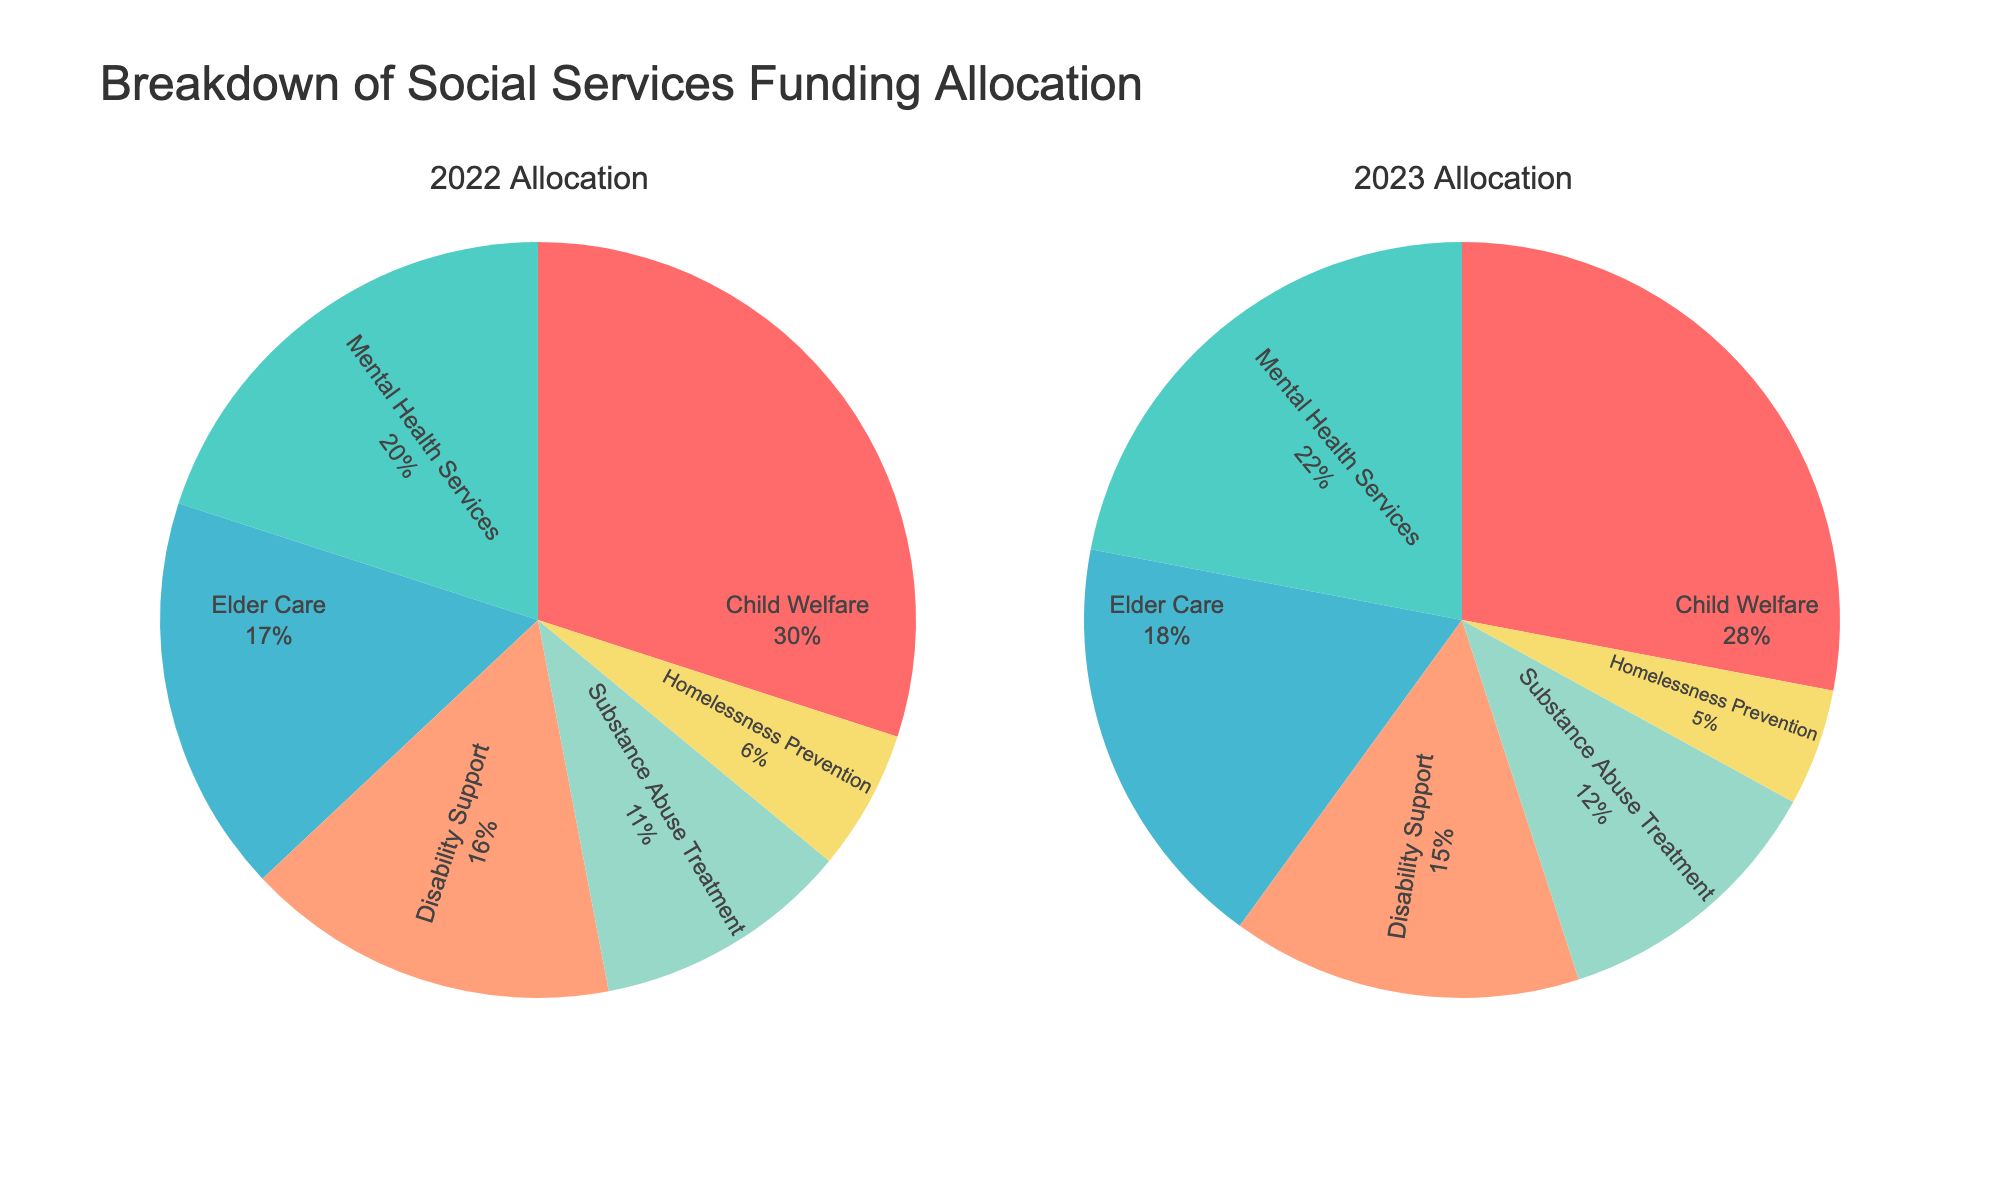Which category received the largest allocation in 2023? By looking at the biggest segment in the 2023 pie chart, we see that Child Welfare has the largest allocation.
Answer: Child Welfare Which category had the smallest percentage allocation in 2022? Looking at the smallest segment in the 2022 pie chart, we see that Homelessness Prevention has the smallest percentage allocation.
Answer: Homelessness Prevention What is the total percentage of allocations for Child Welfare and Mental Health Services in 2023? In the 2023 pie chart, Child Welfare is 28% and Mental Health Services is 22%. Adding these percentages together: 28% + 22% = 50%.
Answer: 50% Which category had an increased percentage of allocation from 2022 to 2023? By comparing the pie charts for both years, we see that the percentages for Mental Health Services and Substance Abuse Treatment increased from 2022 to 2023 (20% to 22% and 11% to 12%, respectively).
Answer: Mental Health Services, Substance Abuse Treatment How did the allocation for Elder Care change from 2022 to 2023? Elder Care's percentage in 2022 was 17% and in 2023 it was 18%. The allocation percentage increased by 1%.
Answer: Increased by 1% What is the combined percentage allocation for Disability Support and Homelessness Prevention in 2022 versus 2023? In 2022, Disability Support is 16% and Homelessness Prevention is 6%, totaling 22% (16% + 6%). In 2023, Disability Support is 15% and Homelessness Prevention is 5%, totaling 20% (15% + 5%).
Answer: 2022: 22%, 2023: 20% Which category experienced a decrease in allocation from 2022 to 2023 and by how much? Child Welfare's allocation decreased from 30% in 2022 to 28% in 2023. The decrease is 2%.
Answer: Child Welfare, decreased by 2% What percentage of the total allocation is for Substance Abuse Treatment across both years? Combining Substance Abuse Treatment's 11% in 2022 and 12% in 2023: (11% + 12%) / 2 = 11.5%.
Answer: 11.5% How do the allocations for Mental Health Services compare between 2022 and 2023? Mental Health Services went from 20% in 2022 to 22% in 2023. The allocation increased by 2%.
Answer: Increased by 2% Identify one category that maintained almost the same percentage allocation between the two years. By comparing both charts, we notice that Elder Care had only a 1% increase, from 17% in 2022 to 18% in 2023, which is nearly the same.
Answer: Elder Care 